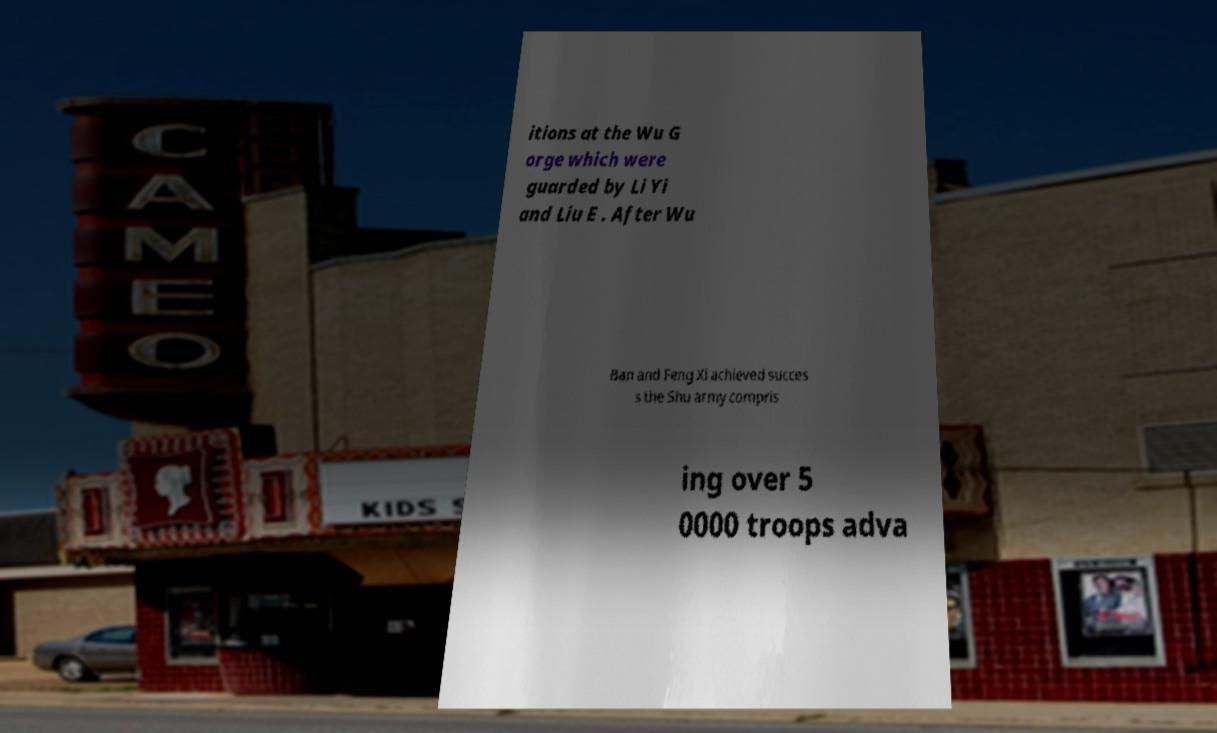Please read and relay the text visible in this image. What does it say? itions at the Wu G orge which were guarded by Li Yi and Liu E . After Wu Ban and Feng Xi achieved succes s the Shu army compris ing over 5 0000 troops adva 